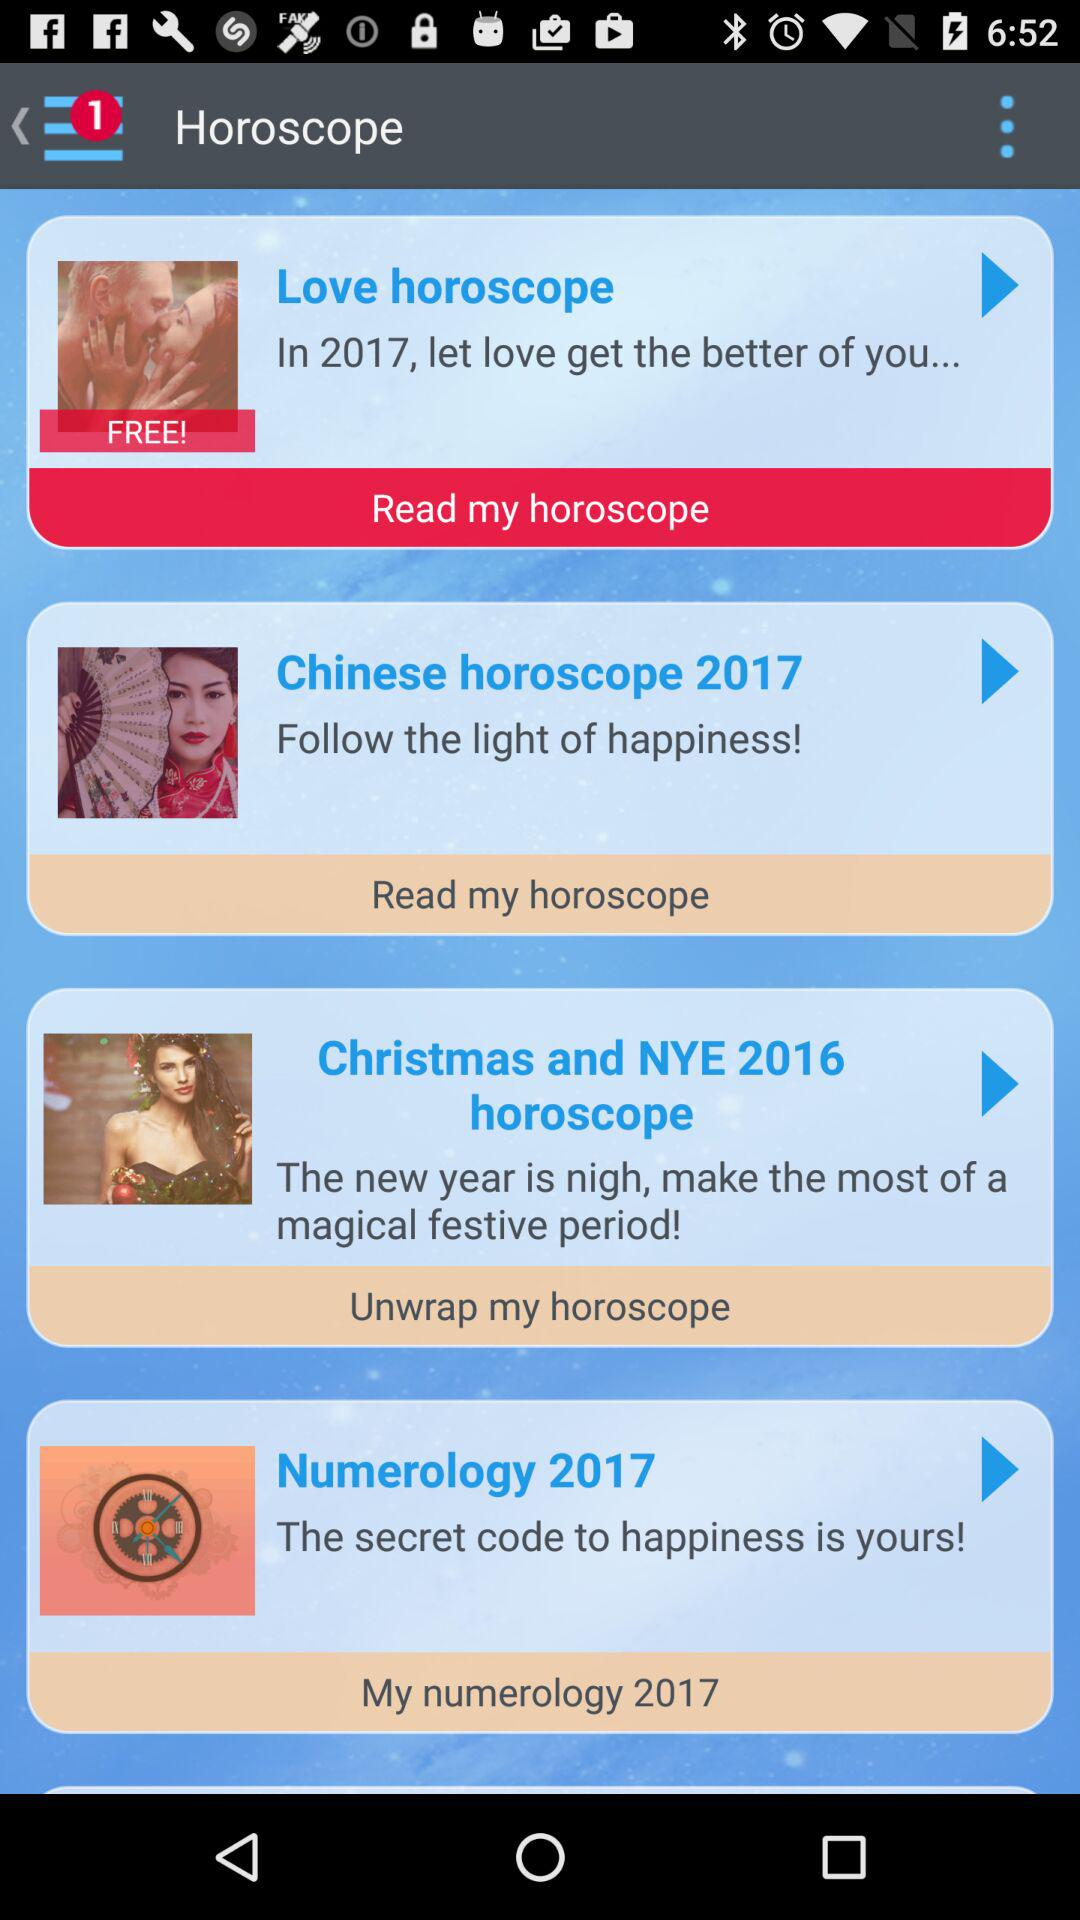Which horoscope is available for free? The horoscope that is available for free is the love horoscope. 